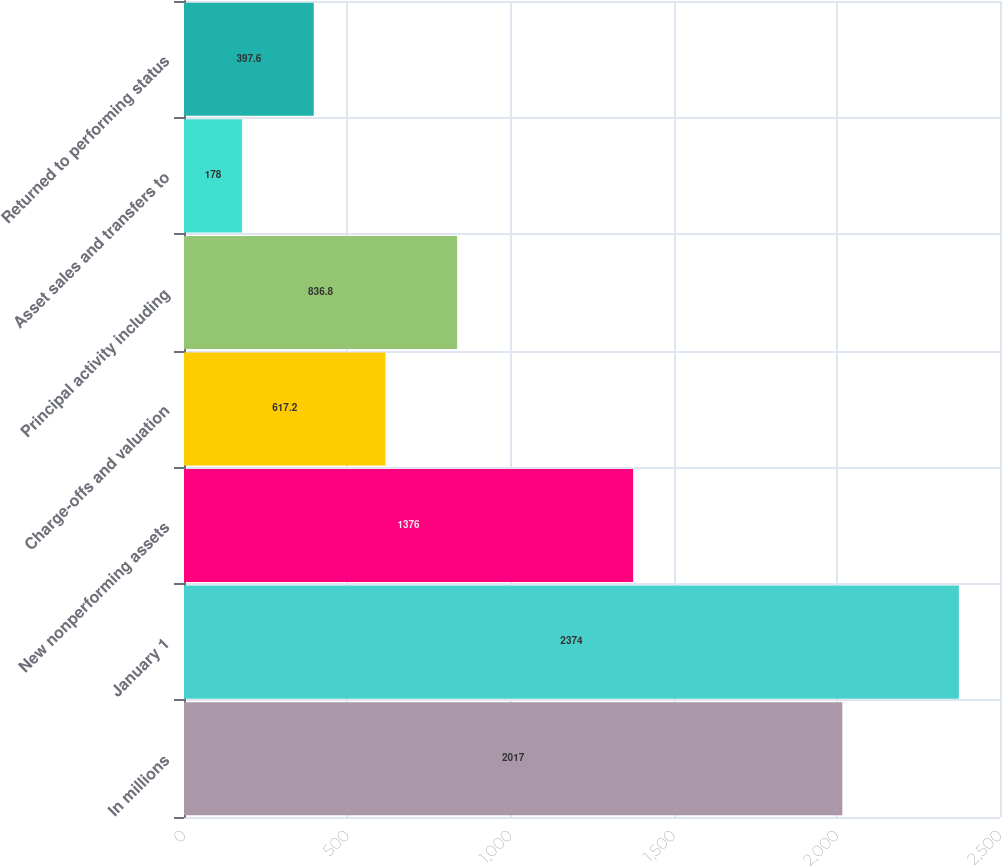<chart> <loc_0><loc_0><loc_500><loc_500><bar_chart><fcel>In millions<fcel>January 1<fcel>New nonperforming assets<fcel>Charge-offs and valuation<fcel>Principal activity including<fcel>Asset sales and transfers to<fcel>Returned to performing status<nl><fcel>2017<fcel>2374<fcel>1376<fcel>617.2<fcel>836.8<fcel>178<fcel>397.6<nl></chart> 